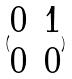<formula> <loc_0><loc_0><loc_500><loc_500>( \begin{matrix} 0 & 1 \\ 0 & 0 \end{matrix} )</formula> 